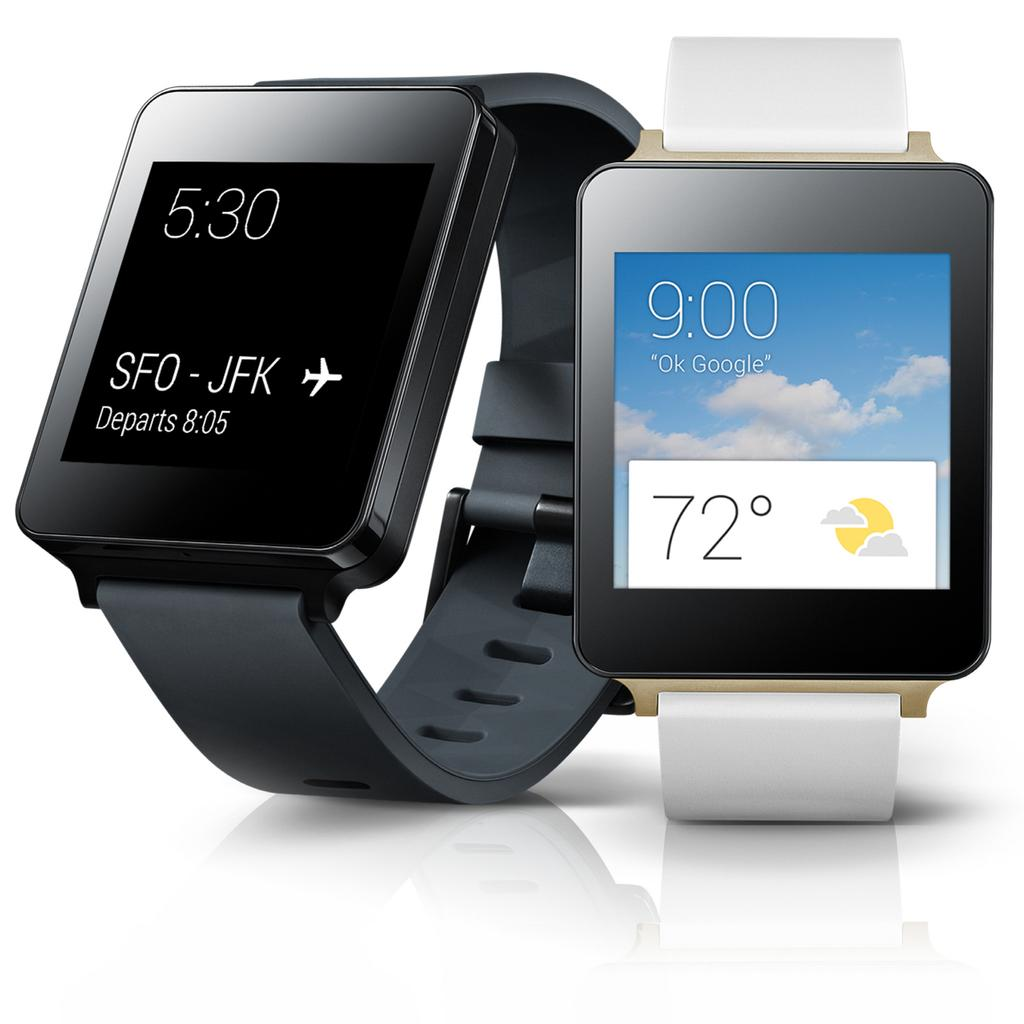Provide a one-sentence caption for the provided image. A black smart watch tells its owner that their flight departs at 8:05. 